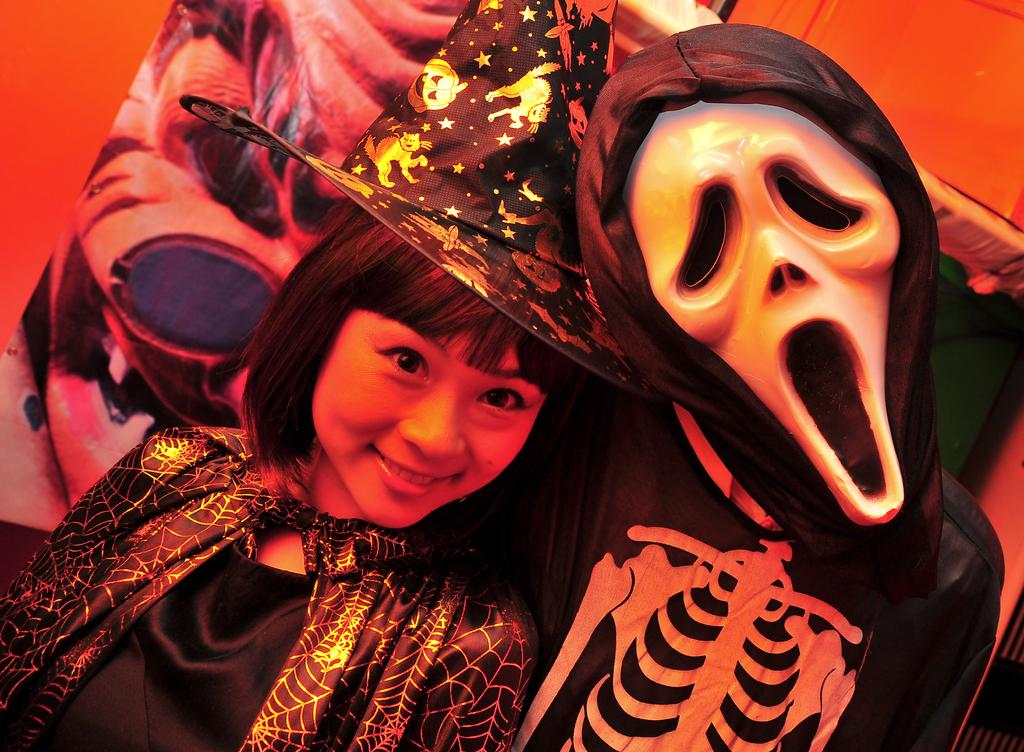What is the main subject of the image? There is a beautiful girl in the image. What is the girl doing in the image? The girl is standing and smiling. Can you describe any other elements in the image? There is a shape resembling a ghost on the right side of the image. What type of copper material can be seen in the image? There is no copper material present in the image. How does the judge react to the girl's smile in the image? There is no judge present in the image, so it's not possible to determine their reaction to the girl's smile. 